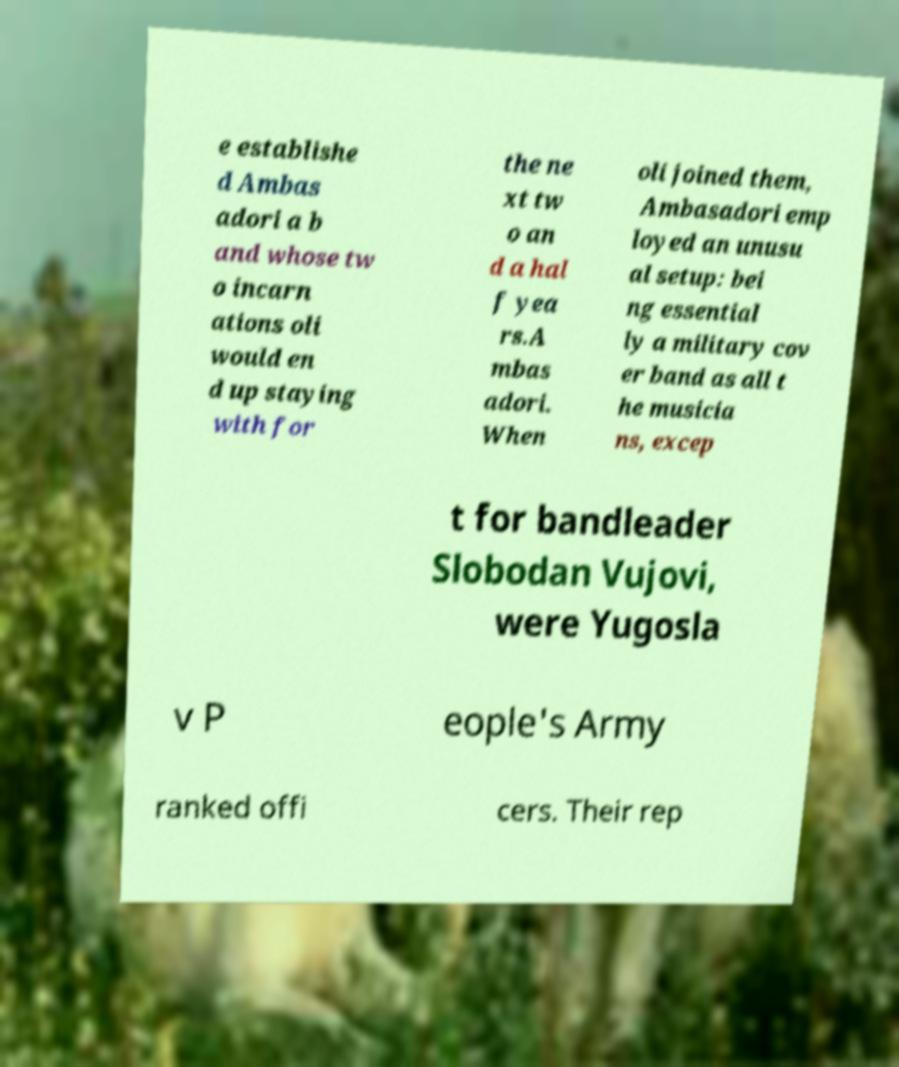There's text embedded in this image that I need extracted. Can you transcribe it verbatim? e establishe d Ambas adori a b and whose tw o incarn ations oli would en d up staying with for the ne xt tw o an d a hal f yea rs.A mbas adori. When oli joined them, Ambasadori emp loyed an unusu al setup: bei ng essential ly a military cov er band as all t he musicia ns, excep t for bandleader Slobodan Vujovi, were Yugosla v P eople's Army ranked offi cers. Their rep 